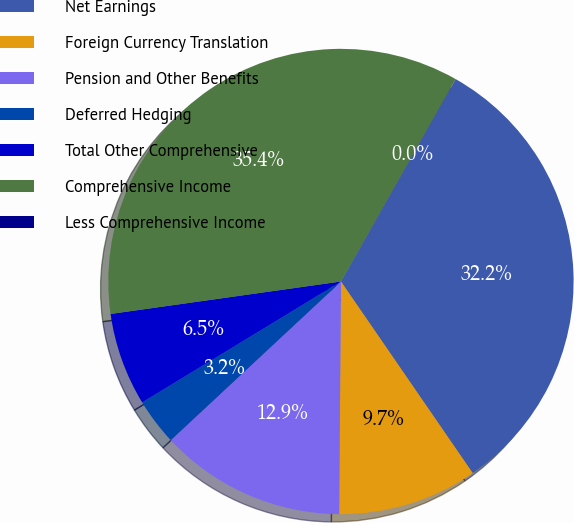Convert chart. <chart><loc_0><loc_0><loc_500><loc_500><pie_chart><fcel>Net Earnings<fcel>Foreign Currency Translation<fcel>Pension and Other Benefits<fcel>Deferred Hedging<fcel>Total Other Comprehensive<fcel>Comprehensive Income<fcel>Less Comprehensive Income<nl><fcel>32.2%<fcel>9.71%<fcel>12.94%<fcel>3.24%<fcel>6.47%<fcel>35.43%<fcel>0.01%<nl></chart> 